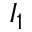<formula> <loc_0><loc_0><loc_500><loc_500>I _ { 1 }</formula> 